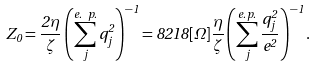Convert formula to latex. <formula><loc_0><loc_0><loc_500><loc_500>Z _ { 0 } = \frac { 2 \eta } { \zeta } \left ( \sum _ { j } ^ { e . \ p . } q _ { j } ^ { 2 } \right ) ^ { - 1 } = 8 2 1 8 [ \Omega ] \frac { \eta } { \zeta } \left ( \sum _ { j } ^ { e . \, p . } \frac { q _ { j } ^ { 2 } } { e ^ { 2 } } \right ) ^ { - 1 } .</formula> 